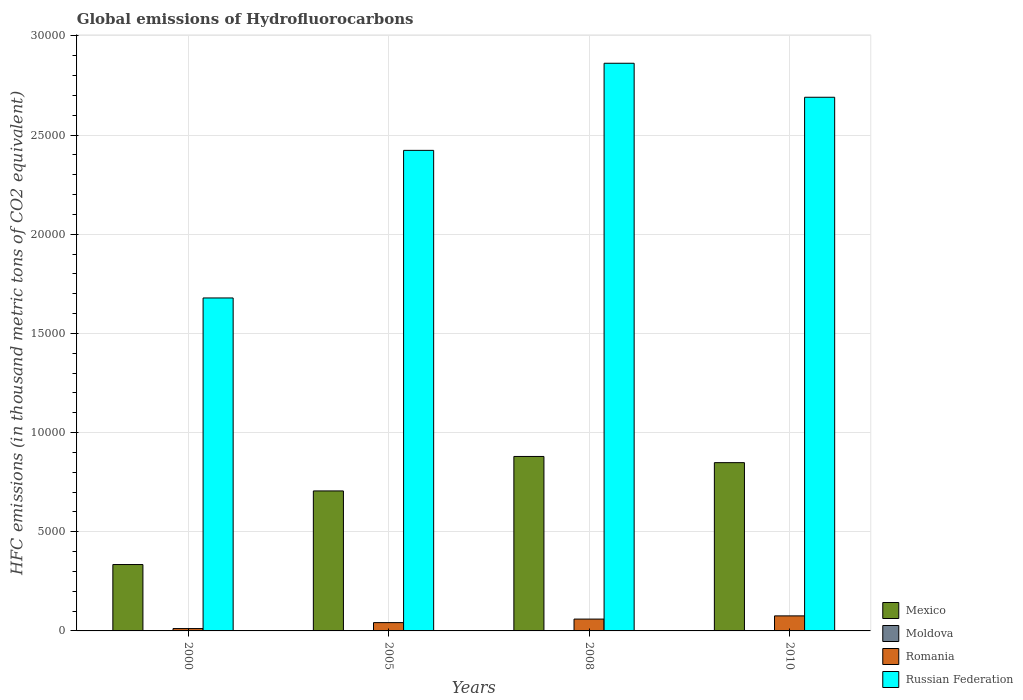Are the number of bars per tick equal to the number of legend labels?
Your response must be concise. Yes. How many bars are there on the 1st tick from the right?
Your response must be concise. 4. What is the label of the 4th group of bars from the left?
Ensure brevity in your answer.  2010. What is the global emissions of Hydrofluorocarbons in Romania in 2005?
Offer a very short reply. 418.8. In which year was the global emissions of Hydrofluorocarbons in Russian Federation maximum?
Keep it short and to the point. 2008. What is the total global emissions of Hydrofluorocarbons in Mexico in the graph?
Your answer should be compact. 2.77e+04. What is the difference between the global emissions of Hydrofluorocarbons in Moldova in 2000 and that in 2010?
Ensure brevity in your answer.  -12.1. What is the difference between the global emissions of Hydrofluorocarbons in Russian Federation in 2000 and the global emissions of Hydrofluorocarbons in Moldova in 2010?
Ensure brevity in your answer.  1.68e+04. What is the average global emissions of Hydrofluorocarbons in Mexico per year?
Provide a short and direct response. 6922.02. In the year 2008, what is the difference between the global emissions of Hydrofluorocarbons in Russian Federation and global emissions of Hydrofluorocarbons in Mexico?
Your answer should be very brief. 1.98e+04. In how many years, is the global emissions of Hydrofluorocarbons in Mexico greater than 11000 thousand metric tons?
Make the answer very short. 0. What is the ratio of the global emissions of Hydrofluorocarbons in Moldova in 2008 to that in 2010?
Make the answer very short. 0.81. Is the global emissions of Hydrofluorocarbons in Mexico in 2000 less than that in 2010?
Provide a succinct answer. Yes. Is the difference between the global emissions of Hydrofluorocarbons in Russian Federation in 2005 and 2008 greater than the difference between the global emissions of Hydrofluorocarbons in Mexico in 2005 and 2008?
Your answer should be very brief. No. What is the difference between the highest and the second highest global emissions of Hydrofluorocarbons in Mexico?
Your answer should be very brief. 311.9. What is the difference between the highest and the lowest global emissions of Hydrofluorocarbons in Moldova?
Offer a terse response. 12.1. In how many years, is the global emissions of Hydrofluorocarbons in Romania greater than the average global emissions of Hydrofluorocarbons in Romania taken over all years?
Provide a succinct answer. 2. Is the sum of the global emissions of Hydrofluorocarbons in Mexico in 2005 and 2010 greater than the maximum global emissions of Hydrofluorocarbons in Romania across all years?
Ensure brevity in your answer.  Yes. Is it the case that in every year, the sum of the global emissions of Hydrofluorocarbons in Russian Federation and global emissions of Hydrofluorocarbons in Romania is greater than the sum of global emissions of Hydrofluorocarbons in Mexico and global emissions of Hydrofluorocarbons in Moldova?
Provide a short and direct response. Yes. What does the 1st bar from the left in 2005 represents?
Offer a terse response. Mexico. What does the 3rd bar from the right in 2005 represents?
Your answer should be very brief. Moldova. Is it the case that in every year, the sum of the global emissions of Hydrofluorocarbons in Russian Federation and global emissions of Hydrofluorocarbons in Moldova is greater than the global emissions of Hydrofluorocarbons in Romania?
Provide a succinct answer. Yes. Are the values on the major ticks of Y-axis written in scientific E-notation?
Offer a terse response. No. Where does the legend appear in the graph?
Offer a very short reply. Bottom right. How many legend labels are there?
Offer a very short reply. 4. How are the legend labels stacked?
Your answer should be compact. Vertical. What is the title of the graph?
Keep it short and to the point. Global emissions of Hydrofluorocarbons. Does "Poland" appear as one of the legend labels in the graph?
Offer a very short reply. No. What is the label or title of the Y-axis?
Offer a very short reply. HFC emissions (in thousand metric tons of CO2 equivalent). What is the HFC emissions (in thousand metric tons of CO2 equivalent) in Mexico in 2000?
Make the answer very short. 3347.3. What is the HFC emissions (in thousand metric tons of CO2 equivalent) in Moldova in 2000?
Your answer should be compact. 1.9. What is the HFC emissions (in thousand metric tons of CO2 equivalent) of Romania in 2000?
Offer a very short reply. 118.2. What is the HFC emissions (in thousand metric tons of CO2 equivalent) of Russian Federation in 2000?
Offer a terse response. 1.68e+04. What is the HFC emissions (in thousand metric tons of CO2 equivalent) in Mexico in 2005?
Your answer should be very brief. 7058.9. What is the HFC emissions (in thousand metric tons of CO2 equivalent) of Romania in 2005?
Give a very brief answer. 418.8. What is the HFC emissions (in thousand metric tons of CO2 equivalent) in Russian Federation in 2005?
Keep it short and to the point. 2.42e+04. What is the HFC emissions (in thousand metric tons of CO2 equivalent) of Mexico in 2008?
Keep it short and to the point. 8796.9. What is the HFC emissions (in thousand metric tons of CO2 equivalent) of Romania in 2008?
Your answer should be compact. 596.4. What is the HFC emissions (in thousand metric tons of CO2 equivalent) in Russian Federation in 2008?
Your response must be concise. 2.86e+04. What is the HFC emissions (in thousand metric tons of CO2 equivalent) in Mexico in 2010?
Your answer should be very brief. 8485. What is the HFC emissions (in thousand metric tons of CO2 equivalent) of Moldova in 2010?
Your answer should be very brief. 14. What is the HFC emissions (in thousand metric tons of CO2 equivalent) in Romania in 2010?
Offer a very short reply. 758. What is the HFC emissions (in thousand metric tons of CO2 equivalent) in Russian Federation in 2010?
Your response must be concise. 2.69e+04. Across all years, what is the maximum HFC emissions (in thousand metric tons of CO2 equivalent) in Mexico?
Your response must be concise. 8796.9. Across all years, what is the maximum HFC emissions (in thousand metric tons of CO2 equivalent) of Romania?
Make the answer very short. 758. Across all years, what is the maximum HFC emissions (in thousand metric tons of CO2 equivalent) in Russian Federation?
Provide a short and direct response. 2.86e+04. Across all years, what is the minimum HFC emissions (in thousand metric tons of CO2 equivalent) in Mexico?
Give a very brief answer. 3347.3. Across all years, what is the minimum HFC emissions (in thousand metric tons of CO2 equivalent) of Moldova?
Your answer should be very brief. 1.9. Across all years, what is the minimum HFC emissions (in thousand metric tons of CO2 equivalent) of Romania?
Provide a succinct answer. 118.2. Across all years, what is the minimum HFC emissions (in thousand metric tons of CO2 equivalent) of Russian Federation?
Give a very brief answer. 1.68e+04. What is the total HFC emissions (in thousand metric tons of CO2 equivalent) in Mexico in the graph?
Provide a short and direct response. 2.77e+04. What is the total HFC emissions (in thousand metric tons of CO2 equivalent) of Moldova in the graph?
Ensure brevity in your answer.  35.2. What is the total HFC emissions (in thousand metric tons of CO2 equivalent) of Romania in the graph?
Keep it short and to the point. 1891.4. What is the total HFC emissions (in thousand metric tons of CO2 equivalent) in Russian Federation in the graph?
Provide a short and direct response. 9.66e+04. What is the difference between the HFC emissions (in thousand metric tons of CO2 equivalent) in Mexico in 2000 and that in 2005?
Make the answer very short. -3711.6. What is the difference between the HFC emissions (in thousand metric tons of CO2 equivalent) of Moldova in 2000 and that in 2005?
Provide a short and direct response. -6.1. What is the difference between the HFC emissions (in thousand metric tons of CO2 equivalent) of Romania in 2000 and that in 2005?
Keep it short and to the point. -300.6. What is the difference between the HFC emissions (in thousand metric tons of CO2 equivalent) of Russian Federation in 2000 and that in 2005?
Your answer should be very brief. -7442.6. What is the difference between the HFC emissions (in thousand metric tons of CO2 equivalent) of Mexico in 2000 and that in 2008?
Offer a terse response. -5449.6. What is the difference between the HFC emissions (in thousand metric tons of CO2 equivalent) in Moldova in 2000 and that in 2008?
Give a very brief answer. -9.4. What is the difference between the HFC emissions (in thousand metric tons of CO2 equivalent) in Romania in 2000 and that in 2008?
Offer a very short reply. -478.2. What is the difference between the HFC emissions (in thousand metric tons of CO2 equivalent) in Russian Federation in 2000 and that in 2008?
Your answer should be very brief. -1.18e+04. What is the difference between the HFC emissions (in thousand metric tons of CO2 equivalent) in Mexico in 2000 and that in 2010?
Give a very brief answer. -5137.7. What is the difference between the HFC emissions (in thousand metric tons of CO2 equivalent) in Romania in 2000 and that in 2010?
Give a very brief answer. -639.8. What is the difference between the HFC emissions (in thousand metric tons of CO2 equivalent) of Russian Federation in 2000 and that in 2010?
Provide a succinct answer. -1.01e+04. What is the difference between the HFC emissions (in thousand metric tons of CO2 equivalent) of Mexico in 2005 and that in 2008?
Give a very brief answer. -1738. What is the difference between the HFC emissions (in thousand metric tons of CO2 equivalent) in Moldova in 2005 and that in 2008?
Provide a succinct answer. -3.3. What is the difference between the HFC emissions (in thousand metric tons of CO2 equivalent) in Romania in 2005 and that in 2008?
Offer a terse response. -177.6. What is the difference between the HFC emissions (in thousand metric tons of CO2 equivalent) of Russian Federation in 2005 and that in 2008?
Make the answer very short. -4392.2. What is the difference between the HFC emissions (in thousand metric tons of CO2 equivalent) of Mexico in 2005 and that in 2010?
Ensure brevity in your answer.  -1426.1. What is the difference between the HFC emissions (in thousand metric tons of CO2 equivalent) in Romania in 2005 and that in 2010?
Your response must be concise. -339.2. What is the difference between the HFC emissions (in thousand metric tons of CO2 equivalent) of Russian Federation in 2005 and that in 2010?
Provide a short and direct response. -2677.7. What is the difference between the HFC emissions (in thousand metric tons of CO2 equivalent) of Mexico in 2008 and that in 2010?
Keep it short and to the point. 311.9. What is the difference between the HFC emissions (in thousand metric tons of CO2 equivalent) of Romania in 2008 and that in 2010?
Offer a terse response. -161.6. What is the difference between the HFC emissions (in thousand metric tons of CO2 equivalent) of Russian Federation in 2008 and that in 2010?
Ensure brevity in your answer.  1714.5. What is the difference between the HFC emissions (in thousand metric tons of CO2 equivalent) of Mexico in 2000 and the HFC emissions (in thousand metric tons of CO2 equivalent) of Moldova in 2005?
Ensure brevity in your answer.  3339.3. What is the difference between the HFC emissions (in thousand metric tons of CO2 equivalent) in Mexico in 2000 and the HFC emissions (in thousand metric tons of CO2 equivalent) in Romania in 2005?
Your answer should be very brief. 2928.5. What is the difference between the HFC emissions (in thousand metric tons of CO2 equivalent) of Mexico in 2000 and the HFC emissions (in thousand metric tons of CO2 equivalent) of Russian Federation in 2005?
Provide a succinct answer. -2.09e+04. What is the difference between the HFC emissions (in thousand metric tons of CO2 equivalent) in Moldova in 2000 and the HFC emissions (in thousand metric tons of CO2 equivalent) in Romania in 2005?
Offer a very short reply. -416.9. What is the difference between the HFC emissions (in thousand metric tons of CO2 equivalent) of Moldova in 2000 and the HFC emissions (in thousand metric tons of CO2 equivalent) of Russian Federation in 2005?
Keep it short and to the point. -2.42e+04. What is the difference between the HFC emissions (in thousand metric tons of CO2 equivalent) of Romania in 2000 and the HFC emissions (in thousand metric tons of CO2 equivalent) of Russian Federation in 2005?
Offer a terse response. -2.41e+04. What is the difference between the HFC emissions (in thousand metric tons of CO2 equivalent) of Mexico in 2000 and the HFC emissions (in thousand metric tons of CO2 equivalent) of Moldova in 2008?
Give a very brief answer. 3336. What is the difference between the HFC emissions (in thousand metric tons of CO2 equivalent) in Mexico in 2000 and the HFC emissions (in thousand metric tons of CO2 equivalent) in Romania in 2008?
Provide a short and direct response. 2750.9. What is the difference between the HFC emissions (in thousand metric tons of CO2 equivalent) in Mexico in 2000 and the HFC emissions (in thousand metric tons of CO2 equivalent) in Russian Federation in 2008?
Provide a short and direct response. -2.53e+04. What is the difference between the HFC emissions (in thousand metric tons of CO2 equivalent) in Moldova in 2000 and the HFC emissions (in thousand metric tons of CO2 equivalent) in Romania in 2008?
Your response must be concise. -594.5. What is the difference between the HFC emissions (in thousand metric tons of CO2 equivalent) in Moldova in 2000 and the HFC emissions (in thousand metric tons of CO2 equivalent) in Russian Federation in 2008?
Your response must be concise. -2.86e+04. What is the difference between the HFC emissions (in thousand metric tons of CO2 equivalent) in Romania in 2000 and the HFC emissions (in thousand metric tons of CO2 equivalent) in Russian Federation in 2008?
Provide a succinct answer. -2.85e+04. What is the difference between the HFC emissions (in thousand metric tons of CO2 equivalent) of Mexico in 2000 and the HFC emissions (in thousand metric tons of CO2 equivalent) of Moldova in 2010?
Your answer should be compact. 3333.3. What is the difference between the HFC emissions (in thousand metric tons of CO2 equivalent) of Mexico in 2000 and the HFC emissions (in thousand metric tons of CO2 equivalent) of Romania in 2010?
Provide a short and direct response. 2589.3. What is the difference between the HFC emissions (in thousand metric tons of CO2 equivalent) of Mexico in 2000 and the HFC emissions (in thousand metric tons of CO2 equivalent) of Russian Federation in 2010?
Give a very brief answer. -2.36e+04. What is the difference between the HFC emissions (in thousand metric tons of CO2 equivalent) of Moldova in 2000 and the HFC emissions (in thousand metric tons of CO2 equivalent) of Romania in 2010?
Your response must be concise. -756.1. What is the difference between the HFC emissions (in thousand metric tons of CO2 equivalent) of Moldova in 2000 and the HFC emissions (in thousand metric tons of CO2 equivalent) of Russian Federation in 2010?
Provide a succinct answer. -2.69e+04. What is the difference between the HFC emissions (in thousand metric tons of CO2 equivalent) of Romania in 2000 and the HFC emissions (in thousand metric tons of CO2 equivalent) of Russian Federation in 2010?
Provide a succinct answer. -2.68e+04. What is the difference between the HFC emissions (in thousand metric tons of CO2 equivalent) in Mexico in 2005 and the HFC emissions (in thousand metric tons of CO2 equivalent) in Moldova in 2008?
Offer a terse response. 7047.6. What is the difference between the HFC emissions (in thousand metric tons of CO2 equivalent) of Mexico in 2005 and the HFC emissions (in thousand metric tons of CO2 equivalent) of Romania in 2008?
Make the answer very short. 6462.5. What is the difference between the HFC emissions (in thousand metric tons of CO2 equivalent) in Mexico in 2005 and the HFC emissions (in thousand metric tons of CO2 equivalent) in Russian Federation in 2008?
Your answer should be very brief. -2.16e+04. What is the difference between the HFC emissions (in thousand metric tons of CO2 equivalent) of Moldova in 2005 and the HFC emissions (in thousand metric tons of CO2 equivalent) of Romania in 2008?
Make the answer very short. -588.4. What is the difference between the HFC emissions (in thousand metric tons of CO2 equivalent) in Moldova in 2005 and the HFC emissions (in thousand metric tons of CO2 equivalent) in Russian Federation in 2008?
Make the answer very short. -2.86e+04. What is the difference between the HFC emissions (in thousand metric tons of CO2 equivalent) of Romania in 2005 and the HFC emissions (in thousand metric tons of CO2 equivalent) of Russian Federation in 2008?
Keep it short and to the point. -2.82e+04. What is the difference between the HFC emissions (in thousand metric tons of CO2 equivalent) in Mexico in 2005 and the HFC emissions (in thousand metric tons of CO2 equivalent) in Moldova in 2010?
Your answer should be compact. 7044.9. What is the difference between the HFC emissions (in thousand metric tons of CO2 equivalent) in Mexico in 2005 and the HFC emissions (in thousand metric tons of CO2 equivalent) in Romania in 2010?
Your response must be concise. 6300.9. What is the difference between the HFC emissions (in thousand metric tons of CO2 equivalent) of Mexico in 2005 and the HFC emissions (in thousand metric tons of CO2 equivalent) of Russian Federation in 2010?
Ensure brevity in your answer.  -1.99e+04. What is the difference between the HFC emissions (in thousand metric tons of CO2 equivalent) of Moldova in 2005 and the HFC emissions (in thousand metric tons of CO2 equivalent) of Romania in 2010?
Offer a terse response. -750. What is the difference between the HFC emissions (in thousand metric tons of CO2 equivalent) in Moldova in 2005 and the HFC emissions (in thousand metric tons of CO2 equivalent) in Russian Federation in 2010?
Your answer should be very brief. -2.69e+04. What is the difference between the HFC emissions (in thousand metric tons of CO2 equivalent) of Romania in 2005 and the HFC emissions (in thousand metric tons of CO2 equivalent) of Russian Federation in 2010?
Your response must be concise. -2.65e+04. What is the difference between the HFC emissions (in thousand metric tons of CO2 equivalent) in Mexico in 2008 and the HFC emissions (in thousand metric tons of CO2 equivalent) in Moldova in 2010?
Offer a very short reply. 8782.9. What is the difference between the HFC emissions (in thousand metric tons of CO2 equivalent) of Mexico in 2008 and the HFC emissions (in thousand metric tons of CO2 equivalent) of Romania in 2010?
Give a very brief answer. 8038.9. What is the difference between the HFC emissions (in thousand metric tons of CO2 equivalent) of Mexico in 2008 and the HFC emissions (in thousand metric tons of CO2 equivalent) of Russian Federation in 2010?
Your answer should be very brief. -1.81e+04. What is the difference between the HFC emissions (in thousand metric tons of CO2 equivalent) in Moldova in 2008 and the HFC emissions (in thousand metric tons of CO2 equivalent) in Romania in 2010?
Your answer should be very brief. -746.7. What is the difference between the HFC emissions (in thousand metric tons of CO2 equivalent) of Moldova in 2008 and the HFC emissions (in thousand metric tons of CO2 equivalent) of Russian Federation in 2010?
Your answer should be compact. -2.69e+04. What is the difference between the HFC emissions (in thousand metric tons of CO2 equivalent) of Romania in 2008 and the HFC emissions (in thousand metric tons of CO2 equivalent) of Russian Federation in 2010?
Provide a short and direct response. -2.63e+04. What is the average HFC emissions (in thousand metric tons of CO2 equivalent) of Mexico per year?
Your response must be concise. 6922.02. What is the average HFC emissions (in thousand metric tons of CO2 equivalent) of Romania per year?
Your answer should be very brief. 472.85. What is the average HFC emissions (in thousand metric tons of CO2 equivalent) of Russian Federation per year?
Provide a succinct answer. 2.41e+04. In the year 2000, what is the difference between the HFC emissions (in thousand metric tons of CO2 equivalent) of Mexico and HFC emissions (in thousand metric tons of CO2 equivalent) of Moldova?
Offer a terse response. 3345.4. In the year 2000, what is the difference between the HFC emissions (in thousand metric tons of CO2 equivalent) in Mexico and HFC emissions (in thousand metric tons of CO2 equivalent) in Romania?
Offer a very short reply. 3229.1. In the year 2000, what is the difference between the HFC emissions (in thousand metric tons of CO2 equivalent) of Mexico and HFC emissions (in thousand metric tons of CO2 equivalent) of Russian Federation?
Keep it short and to the point. -1.34e+04. In the year 2000, what is the difference between the HFC emissions (in thousand metric tons of CO2 equivalent) of Moldova and HFC emissions (in thousand metric tons of CO2 equivalent) of Romania?
Give a very brief answer. -116.3. In the year 2000, what is the difference between the HFC emissions (in thousand metric tons of CO2 equivalent) in Moldova and HFC emissions (in thousand metric tons of CO2 equivalent) in Russian Federation?
Give a very brief answer. -1.68e+04. In the year 2000, what is the difference between the HFC emissions (in thousand metric tons of CO2 equivalent) in Romania and HFC emissions (in thousand metric tons of CO2 equivalent) in Russian Federation?
Keep it short and to the point. -1.67e+04. In the year 2005, what is the difference between the HFC emissions (in thousand metric tons of CO2 equivalent) in Mexico and HFC emissions (in thousand metric tons of CO2 equivalent) in Moldova?
Keep it short and to the point. 7050.9. In the year 2005, what is the difference between the HFC emissions (in thousand metric tons of CO2 equivalent) in Mexico and HFC emissions (in thousand metric tons of CO2 equivalent) in Romania?
Give a very brief answer. 6640.1. In the year 2005, what is the difference between the HFC emissions (in thousand metric tons of CO2 equivalent) in Mexico and HFC emissions (in thousand metric tons of CO2 equivalent) in Russian Federation?
Offer a terse response. -1.72e+04. In the year 2005, what is the difference between the HFC emissions (in thousand metric tons of CO2 equivalent) of Moldova and HFC emissions (in thousand metric tons of CO2 equivalent) of Romania?
Offer a terse response. -410.8. In the year 2005, what is the difference between the HFC emissions (in thousand metric tons of CO2 equivalent) in Moldova and HFC emissions (in thousand metric tons of CO2 equivalent) in Russian Federation?
Offer a terse response. -2.42e+04. In the year 2005, what is the difference between the HFC emissions (in thousand metric tons of CO2 equivalent) in Romania and HFC emissions (in thousand metric tons of CO2 equivalent) in Russian Federation?
Your answer should be very brief. -2.38e+04. In the year 2008, what is the difference between the HFC emissions (in thousand metric tons of CO2 equivalent) in Mexico and HFC emissions (in thousand metric tons of CO2 equivalent) in Moldova?
Keep it short and to the point. 8785.6. In the year 2008, what is the difference between the HFC emissions (in thousand metric tons of CO2 equivalent) in Mexico and HFC emissions (in thousand metric tons of CO2 equivalent) in Romania?
Ensure brevity in your answer.  8200.5. In the year 2008, what is the difference between the HFC emissions (in thousand metric tons of CO2 equivalent) of Mexico and HFC emissions (in thousand metric tons of CO2 equivalent) of Russian Federation?
Make the answer very short. -1.98e+04. In the year 2008, what is the difference between the HFC emissions (in thousand metric tons of CO2 equivalent) of Moldova and HFC emissions (in thousand metric tons of CO2 equivalent) of Romania?
Your answer should be compact. -585.1. In the year 2008, what is the difference between the HFC emissions (in thousand metric tons of CO2 equivalent) of Moldova and HFC emissions (in thousand metric tons of CO2 equivalent) of Russian Federation?
Provide a succinct answer. -2.86e+04. In the year 2008, what is the difference between the HFC emissions (in thousand metric tons of CO2 equivalent) in Romania and HFC emissions (in thousand metric tons of CO2 equivalent) in Russian Federation?
Ensure brevity in your answer.  -2.80e+04. In the year 2010, what is the difference between the HFC emissions (in thousand metric tons of CO2 equivalent) in Mexico and HFC emissions (in thousand metric tons of CO2 equivalent) in Moldova?
Offer a terse response. 8471. In the year 2010, what is the difference between the HFC emissions (in thousand metric tons of CO2 equivalent) in Mexico and HFC emissions (in thousand metric tons of CO2 equivalent) in Romania?
Provide a succinct answer. 7727. In the year 2010, what is the difference between the HFC emissions (in thousand metric tons of CO2 equivalent) in Mexico and HFC emissions (in thousand metric tons of CO2 equivalent) in Russian Federation?
Your answer should be very brief. -1.84e+04. In the year 2010, what is the difference between the HFC emissions (in thousand metric tons of CO2 equivalent) of Moldova and HFC emissions (in thousand metric tons of CO2 equivalent) of Romania?
Provide a short and direct response. -744. In the year 2010, what is the difference between the HFC emissions (in thousand metric tons of CO2 equivalent) of Moldova and HFC emissions (in thousand metric tons of CO2 equivalent) of Russian Federation?
Keep it short and to the point. -2.69e+04. In the year 2010, what is the difference between the HFC emissions (in thousand metric tons of CO2 equivalent) in Romania and HFC emissions (in thousand metric tons of CO2 equivalent) in Russian Federation?
Offer a terse response. -2.62e+04. What is the ratio of the HFC emissions (in thousand metric tons of CO2 equivalent) of Mexico in 2000 to that in 2005?
Your response must be concise. 0.47. What is the ratio of the HFC emissions (in thousand metric tons of CO2 equivalent) in Moldova in 2000 to that in 2005?
Provide a succinct answer. 0.24. What is the ratio of the HFC emissions (in thousand metric tons of CO2 equivalent) of Romania in 2000 to that in 2005?
Give a very brief answer. 0.28. What is the ratio of the HFC emissions (in thousand metric tons of CO2 equivalent) in Russian Federation in 2000 to that in 2005?
Provide a short and direct response. 0.69. What is the ratio of the HFC emissions (in thousand metric tons of CO2 equivalent) in Mexico in 2000 to that in 2008?
Ensure brevity in your answer.  0.38. What is the ratio of the HFC emissions (in thousand metric tons of CO2 equivalent) of Moldova in 2000 to that in 2008?
Your response must be concise. 0.17. What is the ratio of the HFC emissions (in thousand metric tons of CO2 equivalent) of Romania in 2000 to that in 2008?
Your answer should be compact. 0.2. What is the ratio of the HFC emissions (in thousand metric tons of CO2 equivalent) of Russian Federation in 2000 to that in 2008?
Make the answer very short. 0.59. What is the ratio of the HFC emissions (in thousand metric tons of CO2 equivalent) of Mexico in 2000 to that in 2010?
Your answer should be very brief. 0.39. What is the ratio of the HFC emissions (in thousand metric tons of CO2 equivalent) in Moldova in 2000 to that in 2010?
Make the answer very short. 0.14. What is the ratio of the HFC emissions (in thousand metric tons of CO2 equivalent) of Romania in 2000 to that in 2010?
Your response must be concise. 0.16. What is the ratio of the HFC emissions (in thousand metric tons of CO2 equivalent) of Russian Federation in 2000 to that in 2010?
Provide a succinct answer. 0.62. What is the ratio of the HFC emissions (in thousand metric tons of CO2 equivalent) in Mexico in 2005 to that in 2008?
Provide a short and direct response. 0.8. What is the ratio of the HFC emissions (in thousand metric tons of CO2 equivalent) in Moldova in 2005 to that in 2008?
Keep it short and to the point. 0.71. What is the ratio of the HFC emissions (in thousand metric tons of CO2 equivalent) in Romania in 2005 to that in 2008?
Your answer should be compact. 0.7. What is the ratio of the HFC emissions (in thousand metric tons of CO2 equivalent) in Russian Federation in 2005 to that in 2008?
Offer a terse response. 0.85. What is the ratio of the HFC emissions (in thousand metric tons of CO2 equivalent) of Mexico in 2005 to that in 2010?
Your response must be concise. 0.83. What is the ratio of the HFC emissions (in thousand metric tons of CO2 equivalent) in Romania in 2005 to that in 2010?
Your answer should be compact. 0.55. What is the ratio of the HFC emissions (in thousand metric tons of CO2 equivalent) in Russian Federation in 2005 to that in 2010?
Your answer should be very brief. 0.9. What is the ratio of the HFC emissions (in thousand metric tons of CO2 equivalent) of Mexico in 2008 to that in 2010?
Offer a very short reply. 1.04. What is the ratio of the HFC emissions (in thousand metric tons of CO2 equivalent) of Moldova in 2008 to that in 2010?
Provide a short and direct response. 0.81. What is the ratio of the HFC emissions (in thousand metric tons of CO2 equivalent) of Romania in 2008 to that in 2010?
Give a very brief answer. 0.79. What is the ratio of the HFC emissions (in thousand metric tons of CO2 equivalent) of Russian Federation in 2008 to that in 2010?
Your response must be concise. 1.06. What is the difference between the highest and the second highest HFC emissions (in thousand metric tons of CO2 equivalent) of Mexico?
Keep it short and to the point. 311.9. What is the difference between the highest and the second highest HFC emissions (in thousand metric tons of CO2 equivalent) of Moldova?
Your response must be concise. 2.7. What is the difference between the highest and the second highest HFC emissions (in thousand metric tons of CO2 equivalent) of Romania?
Your response must be concise. 161.6. What is the difference between the highest and the second highest HFC emissions (in thousand metric tons of CO2 equivalent) in Russian Federation?
Give a very brief answer. 1714.5. What is the difference between the highest and the lowest HFC emissions (in thousand metric tons of CO2 equivalent) in Mexico?
Provide a succinct answer. 5449.6. What is the difference between the highest and the lowest HFC emissions (in thousand metric tons of CO2 equivalent) of Moldova?
Your response must be concise. 12.1. What is the difference between the highest and the lowest HFC emissions (in thousand metric tons of CO2 equivalent) in Romania?
Keep it short and to the point. 639.8. What is the difference between the highest and the lowest HFC emissions (in thousand metric tons of CO2 equivalent) of Russian Federation?
Give a very brief answer. 1.18e+04. 